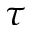Convert formula to latex. <formula><loc_0><loc_0><loc_500><loc_500>\tau</formula> 